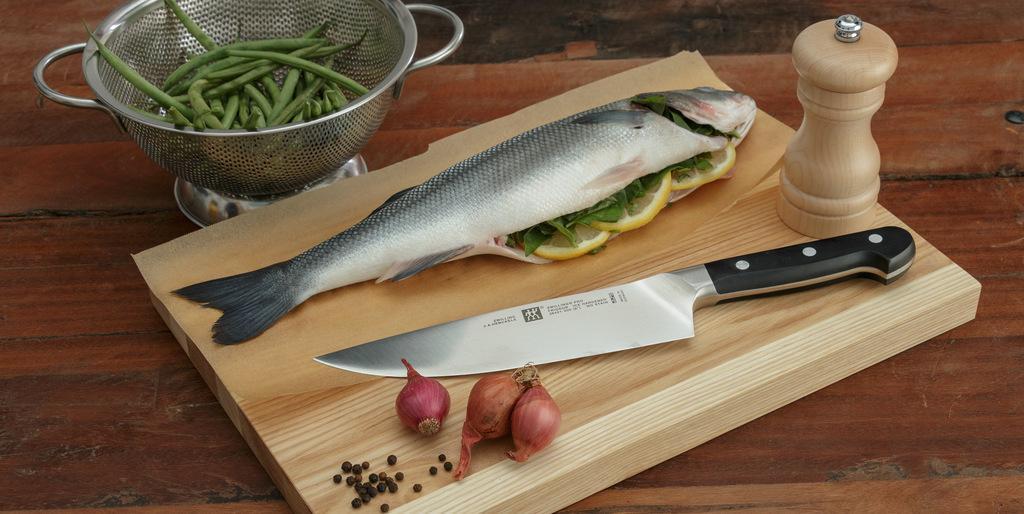Describe this image in one or two sentences. In the center of the image there is a table on which there is a chopping board. There is a knife on the chopping board. There is a fish on the chopping board. There are few onions. Besides the chopping board there is a bowl with beans in it. 